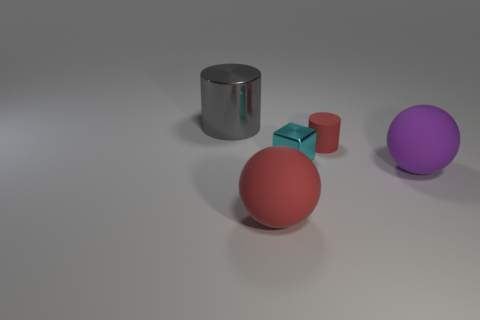There is a sphere that is to the left of the matte ball on the right side of the cube; are there any cylinders right of it?
Provide a succinct answer. Yes. Does the big matte object that is to the left of the small cylinder have the same shape as the large object right of the small cube?
Provide a short and direct response. Yes. There is another sphere that is the same material as the big purple ball; what is its color?
Offer a terse response. Red. Is the number of tiny metal things in front of the purple matte ball less than the number of cyan metallic things?
Provide a succinct answer. Yes. There is a red thing that is behind the large ball in front of the matte ball right of the tiny cyan thing; what is its size?
Your answer should be very brief. Small. Is the red object behind the tiny cyan block made of the same material as the gray object?
Keep it short and to the point. No. Are there any other things that are the same shape as the tiny metallic object?
Keep it short and to the point. No. What number of things are either big cyan metal things or shiny cylinders?
Ensure brevity in your answer.  1. What size is the red matte object that is the same shape as the purple rubber thing?
Provide a succinct answer. Large. Are there any other things that are the same size as the block?
Provide a succinct answer. Yes. 